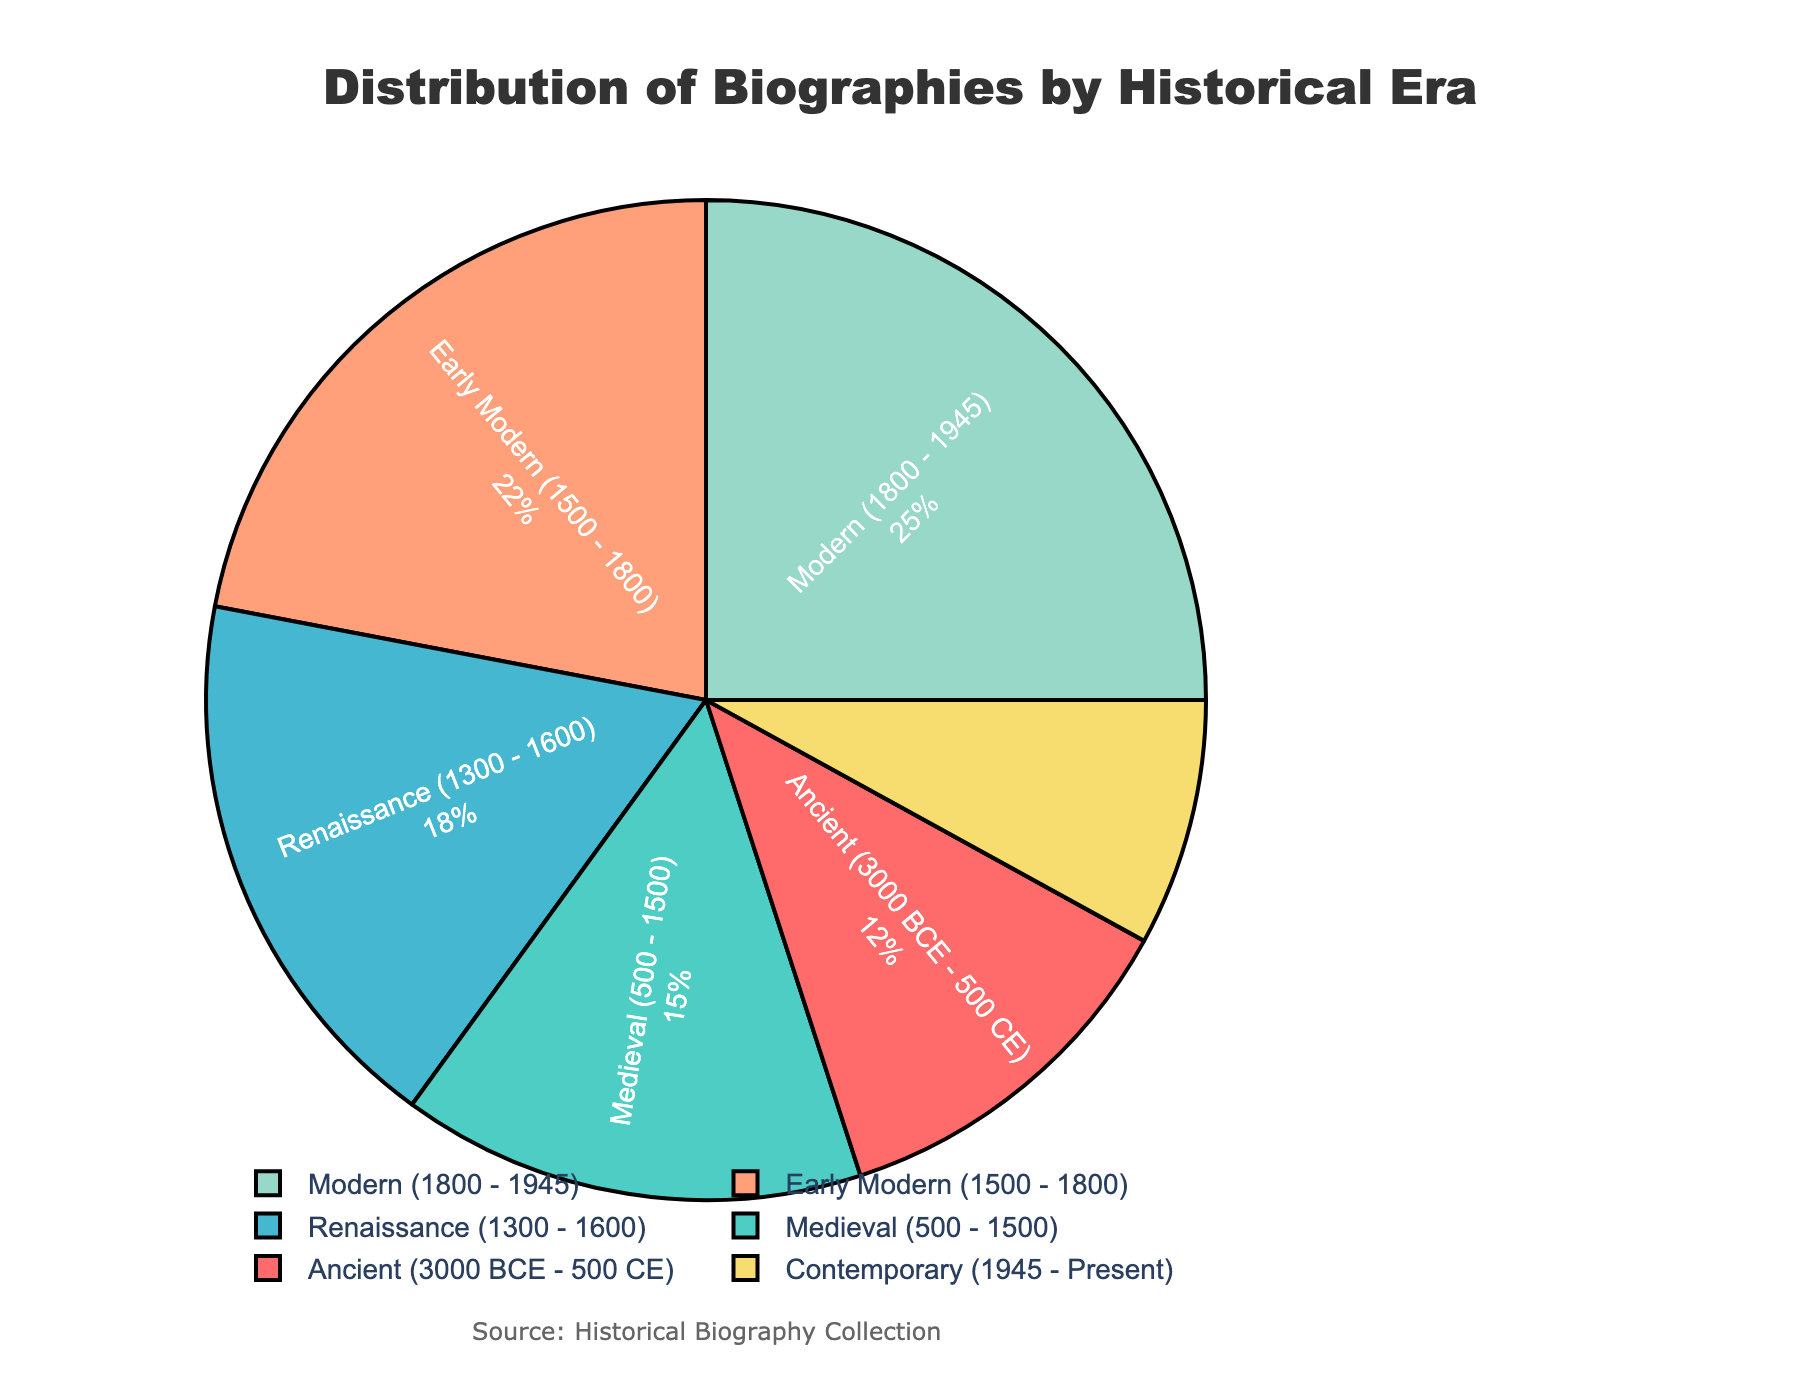What era has the largest distribution of biographies? By looking at the pie chart, we can observe that the largest section is labeled "Modern (1800 - 1945)" and occupies the biggest area, indicating it has the largest percentage.
Answer: Modern (1800 - 1945) Which era has the smallest distribution of biographies? The smallest section on the pie chart is labeled "Contemporary (1945 - Present)" and has the smallest area, signifying the smallest percentage.
Answer: Contemporary (1945 - Present) What is the combined percentage of biographies from the Renaissance and Early Modern eras? To find the combined percentage, sum the values of Renaissance (18) and Early Modern (22): 18 + 22 = 40.
Answer: 40% How does the percentage of Medieval biographies compare to Contemporary biographies? The pie chart shows 15% for Medieval and 8% for Contemporary, which means Medieval has a higher percentage.
Answer: Medieval has a higher percentage Which color represents the Ancient era in the pie chart? By identifying the colored segments and matching them with the labels, we see that the Ancient era is represented by red.
Answer: Red What is the percentage difference between the eras with the highest and lowest distribution of biographies? To find the difference, subtract the percentage of the smallest (8, Contemporary) from the largest (25, Modern): 25 - 8 = 17.
Answer: 17% What's the total percentage of biographies in the combined Modern and Contemporary eras? Combine the percentages for Modern (25) and Contemporary (8) by adding them together: 25 + 8 = 33.
Answer: 33% Is the distribution of Renaissance biographies greater than that of Medieval biographies? According to the pie chart, the Renaissance era has 18% while the Medieval era has 15%, indicating it is greater.
Answer: Yes What is the average percentage of biographies across all eras? To find the average, sum all percentages and divide by the number of eras: (12 + 15 + 18 + 22 + 25 + 8) / 6 = 16.67.
Answer: 16.67% Which era is represented with a light green color? Using visual identification from the pie chart, light green correlates with the Medieval era.
Answer: Medieval 